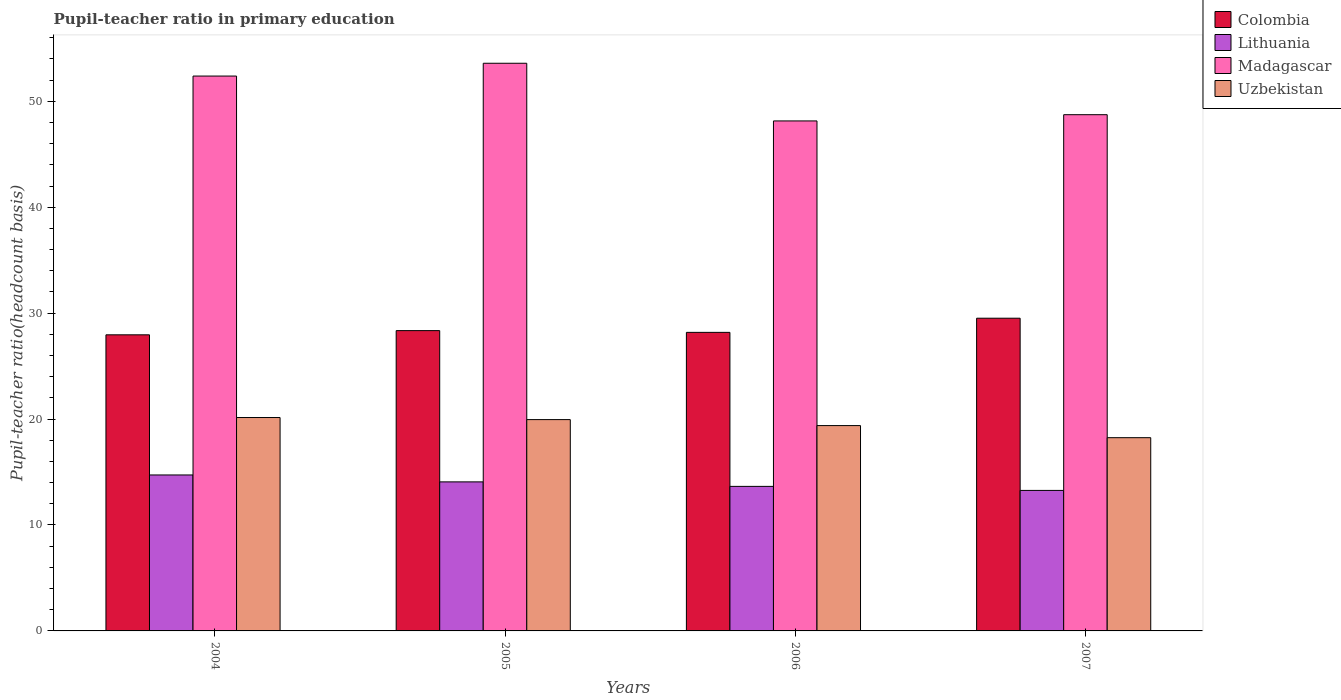Are the number of bars on each tick of the X-axis equal?
Your answer should be very brief. Yes. How many bars are there on the 3rd tick from the right?
Provide a short and direct response. 4. In how many cases, is the number of bars for a given year not equal to the number of legend labels?
Make the answer very short. 0. What is the pupil-teacher ratio in primary education in Lithuania in 2004?
Give a very brief answer. 14.72. Across all years, what is the maximum pupil-teacher ratio in primary education in Lithuania?
Offer a terse response. 14.72. Across all years, what is the minimum pupil-teacher ratio in primary education in Uzbekistan?
Offer a very short reply. 18.24. What is the total pupil-teacher ratio in primary education in Madagascar in the graph?
Offer a very short reply. 202.84. What is the difference between the pupil-teacher ratio in primary education in Madagascar in 2005 and that in 2007?
Your response must be concise. 4.86. What is the difference between the pupil-teacher ratio in primary education in Uzbekistan in 2005 and the pupil-teacher ratio in primary education in Colombia in 2004?
Keep it short and to the point. -8. What is the average pupil-teacher ratio in primary education in Colombia per year?
Your answer should be compact. 28.5. In the year 2007, what is the difference between the pupil-teacher ratio in primary education in Madagascar and pupil-teacher ratio in primary education in Uzbekistan?
Keep it short and to the point. 30.49. What is the ratio of the pupil-teacher ratio in primary education in Lithuania in 2004 to that in 2005?
Make the answer very short. 1.05. What is the difference between the highest and the second highest pupil-teacher ratio in primary education in Lithuania?
Ensure brevity in your answer.  0.65. What is the difference between the highest and the lowest pupil-teacher ratio in primary education in Uzbekistan?
Make the answer very short. 1.9. Is the sum of the pupil-teacher ratio in primary education in Madagascar in 2004 and 2006 greater than the maximum pupil-teacher ratio in primary education in Uzbekistan across all years?
Provide a succinct answer. Yes. Is it the case that in every year, the sum of the pupil-teacher ratio in primary education in Uzbekistan and pupil-teacher ratio in primary education in Lithuania is greater than the sum of pupil-teacher ratio in primary education in Madagascar and pupil-teacher ratio in primary education in Colombia?
Give a very brief answer. No. What does the 2nd bar from the left in 2006 represents?
Your response must be concise. Lithuania. What does the 2nd bar from the right in 2004 represents?
Offer a very short reply. Madagascar. Is it the case that in every year, the sum of the pupil-teacher ratio in primary education in Madagascar and pupil-teacher ratio in primary education in Colombia is greater than the pupil-teacher ratio in primary education in Uzbekistan?
Give a very brief answer. Yes. How many bars are there?
Your answer should be compact. 16. Are all the bars in the graph horizontal?
Your response must be concise. No. How many years are there in the graph?
Your answer should be very brief. 4. What is the difference between two consecutive major ticks on the Y-axis?
Give a very brief answer. 10. Are the values on the major ticks of Y-axis written in scientific E-notation?
Provide a short and direct response. No. Does the graph contain any zero values?
Offer a very short reply. No. Does the graph contain grids?
Your answer should be compact. No. Where does the legend appear in the graph?
Ensure brevity in your answer.  Top right. What is the title of the graph?
Keep it short and to the point. Pupil-teacher ratio in primary education. Does "Cyprus" appear as one of the legend labels in the graph?
Offer a very short reply. No. What is the label or title of the Y-axis?
Keep it short and to the point. Pupil-teacher ratio(headcount basis). What is the Pupil-teacher ratio(headcount basis) in Colombia in 2004?
Give a very brief answer. 27.95. What is the Pupil-teacher ratio(headcount basis) of Lithuania in 2004?
Keep it short and to the point. 14.72. What is the Pupil-teacher ratio(headcount basis) in Madagascar in 2004?
Make the answer very short. 52.38. What is the Pupil-teacher ratio(headcount basis) in Uzbekistan in 2004?
Keep it short and to the point. 20.15. What is the Pupil-teacher ratio(headcount basis) of Colombia in 2005?
Make the answer very short. 28.35. What is the Pupil-teacher ratio(headcount basis) in Lithuania in 2005?
Your response must be concise. 14.07. What is the Pupil-teacher ratio(headcount basis) of Madagascar in 2005?
Make the answer very short. 53.59. What is the Pupil-teacher ratio(headcount basis) in Uzbekistan in 2005?
Offer a terse response. 19.95. What is the Pupil-teacher ratio(headcount basis) of Colombia in 2006?
Your answer should be very brief. 28.18. What is the Pupil-teacher ratio(headcount basis) in Lithuania in 2006?
Provide a succinct answer. 13.64. What is the Pupil-teacher ratio(headcount basis) in Madagascar in 2006?
Keep it short and to the point. 48.14. What is the Pupil-teacher ratio(headcount basis) in Uzbekistan in 2006?
Make the answer very short. 19.38. What is the Pupil-teacher ratio(headcount basis) in Colombia in 2007?
Offer a terse response. 29.52. What is the Pupil-teacher ratio(headcount basis) of Lithuania in 2007?
Make the answer very short. 13.26. What is the Pupil-teacher ratio(headcount basis) of Madagascar in 2007?
Provide a succinct answer. 48.73. What is the Pupil-teacher ratio(headcount basis) of Uzbekistan in 2007?
Provide a short and direct response. 18.24. Across all years, what is the maximum Pupil-teacher ratio(headcount basis) in Colombia?
Your answer should be compact. 29.52. Across all years, what is the maximum Pupil-teacher ratio(headcount basis) of Lithuania?
Provide a succinct answer. 14.72. Across all years, what is the maximum Pupil-teacher ratio(headcount basis) in Madagascar?
Your response must be concise. 53.59. Across all years, what is the maximum Pupil-teacher ratio(headcount basis) of Uzbekistan?
Make the answer very short. 20.15. Across all years, what is the minimum Pupil-teacher ratio(headcount basis) of Colombia?
Offer a very short reply. 27.95. Across all years, what is the minimum Pupil-teacher ratio(headcount basis) in Lithuania?
Your answer should be very brief. 13.26. Across all years, what is the minimum Pupil-teacher ratio(headcount basis) in Madagascar?
Your response must be concise. 48.14. Across all years, what is the minimum Pupil-teacher ratio(headcount basis) of Uzbekistan?
Give a very brief answer. 18.24. What is the total Pupil-teacher ratio(headcount basis) in Colombia in the graph?
Provide a short and direct response. 114. What is the total Pupil-teacher ratio(headcount basis) in Lithuania in the graph?
Your response must be concise. 55.7. What is the total Pupil-teacher ratio(headcount basis) in Madagascar in the graph?
Ensure brevity in your answer.  202.84. What is the total Pupil-teacher ratio(headcount basis) of Uzbekistan in the graph?
Offer a very short reply. 77.72. What is the difference between the Pupil-teacher ratio(headcount basis) in Colombia in 2004 and that in 2005?
Provide a short and direct response. -0.4. What is the difference between the Pupil-teacher ratio(headcount basis) in Lithuania in 2004 and that in 2005?
Ensure brevity in your answer.  0.65. What is the difference between the Pupil-teacher ratio(headcount basis) in Madagascar in 2004 and that in 2005?
Your response must be concise. -1.21. What is the difference between the Pupil-teacher ratio(headcount basis) in Uzbekistan in 2004 and that in 2005?
Give a very brief answer. 0.2. What is the difference between the Pupil-teacher ratio(headcount basis) of Colombia in 2004 and that in 2006?
Provide a short and direct response. -0.23. What is the difference between the Pupil-teacher ratio(headcount basis) of Lithuania in 2004 and that in 2006?
Keep it short and to the point. 1.08. What is the difference between the Pupil-teacher ratio(headcount basis) of Madagascar in 2004 and that in 2006?
Your response must be concise. 4.24. What is the difference between the Pupil-teacher ratio(headcount basis) in Uzbekistan in 2004 and that in 2006?
Offer a terse response. 0.76. What is the difference between the Pupil-teacher ratio(headcount basis) in Colombia in 2004 and that in 2007?
Your answer should be compact. -1.57. What is the difference between the Pupil-teacher ratio(headcount basis) of Lithuania in 2004 and that in 2007?
Offer a terse response. 1.46. What is the difference between the Pupil-teacher ratio(headcount basis) in Madagascar in 2004 and that in 2007?
Offer a very short reply. 3.65. What is the difference between the Pupil-teacher ratio(headcount basis) of Uzbekistan in 2004 and that in 2007?
Make the answer very short. 1.9. What is the difference between the Pupil-teacher ratio(headcount basis) in Colombia in 2005 and that in 2006?
Give a very brief answer. 0.17. What is the difference between the Pupil-teacher ratio(headcount basis) in Lithuania in 2005 and that in 2006?
Provide a short and direct response. 0.43. What is the difference between the Pupil-teacher ratio(headcount basis) in Madagascar in 2005 and that in 2006?
Give a very brief answer. 5.44. What is the difference between the Pupil-teacher ratio(headcount basis) in Uzbekistan in 2005 and that in 2006?
Offer a very short reply. 0.57. What is the difference between the Pupil-teacher ratio(headcount basis) in Colombia in 2005 and that in 2007?
Your answer should be very brief. -1.17. What is the difference between the Pupil-teacher ratio(headcount basis) in Lithuania in 2005 and that in 2007?
Ensure brevity in your answer.  0.81. What is the difference between the Pupil-teacher ratio(headcount basis) of Madagascar in 2005 and that in 2007?
Give a very brief answer. 4.86. What is the difference between the Pupil-teacher ratio(headcount basis) in Uzbekistan in 2005 and that in 2007?
Provide a succinct answer. 1.71. What is the difference between the Pupil-teacher ratio(headcount basis) of Colombia in 2006 and that in 2007?
Make the answer very short. -1.34. What is the difference between the Pupil-teacher ratio(headcount basis) of Lithuania in 2006 and that in 2007?
Provide a succinct answer. 0.38. What is the difference between the Pupil-teacher ratio(headcount basis) of Madagascar in 2006 and that in 2007?
Make the answer very short. -0.59. What is the difference between the Pupil-teacher ratio(headcount basis) of Uzbekistan in 2006 and that in 2007?
Give a very brief answer. 1.14. What is the difference between the Pupil-teacher ratio(headcount basis) in Colombia in 2004 and the Pupil-teacher ratio(headcount basis) in Lithuania in 2005?
Your answer should be compact. 13.88. What is the difference between the Pupil-teacher ratio(headcount basis) in Colombia in 2004 and the Pupil-teacher ratio(headcount basis) in Madagascar in 2005?
Give a very brief answer. -25.64. What is the difference between the Pupil-teacher ratio(headcount basis) of Colombia in 2004 and the Pupil-teacher ratio(headcount basis) of Uzbekistan in 2005?
Provide a succinct answer. 8. What is the difference between the Pupil-teacher ratio(headcount basis) of Lithuania in 2004 and the Pupil-teacher ratio(headcount basis) of Madagascar in 2005?
Provide a succinct answer. -38.86. What is the difference between the Pupil-teacher ratio(headcount basis) of Lithuania in 2004 and the Pupil-teacher ratio(headcount basis) of Uzbekistan in 2005?
Give a very brief answer. -5.23. What is the difference between the Pupil-teacher ratio(headcount basis) of Madagascar in 2004 and the Pupil-teacher ratio(headcount basis) of Uzbekistan in 2005?
Offer a very short reply. 32.43. What is the difference between the Pupil-teacher ratio(headcount basis) in Colombia in 2004 and the Pupil-teacher ratio(headcount basis) in Lithuania in 2006?
Provide a succinct answer. 14.31. What is the difference between the Pupil-teacher ratio(headcount basis) in Colombia in 2004 and the Pupil-teacher ratio(headcount basis) in Madagascar in 2006?
Your response must be concise. -20.19. What is the difference between the Pupil-teacher ratio(headcount basis) in Colombia in 2004 and the Pupil-teacher ratio(headcount basis) in Uzbekistan in 2006?
Give a very brief answer. 8.57. What is the difference between the Pupil-teacher ratio(headcount basis) in Lithuania in 2004 and the Pupil-teacher ratio(headcount basis) in Madagascar in 2006?
Offer a very short reply. -33.42. What is the difference between the Pupil-teacher ratio(headcount basis) in Lithuania in 2004 and the Pupil-teacher ratio(headcount basis) in Uzbekistan in 2006?
Offer a very short reply. -4.66. What is the difference between the Pupil-teacher ratio(headcount basis) of Madagascar in 2004 and the Pupil-teacher ratio(headcount basis) of Uzbekistan in 2006?
Make the answer very short. 33. What is the difference between the Pupil-teacher ratio(headcount basis) in Colombia in 2004 and the Pupil-teacher ratio(headcount basis) in Lithuania in 2007?
Offer a very short reply. 14.69. What is the difference between the Pupil-teacher ratio(headcount basis) in Colombia in 2004 and the Pupil-teacher ratio(headcount basis) in Madagascar in 2007?
Ensure brevity in your answer.  -20.78. What is the difference between the Pupil-teacher ratio(headcount basis) in Colombia in 2004 and the Pupil-teacher ratio(headcount basis) in Uzbekistan in 2007?
Give a very brief answer. 9.71. What is the difference between the Pupil-teacher ratio(headcount basis) in Lithuania in 2004 and the Pupil-teacher ratio(headcount basis) in Madagascar in 2007?
Your response must be concise. -34.01. What is the difference between the Pupil-teacher ratio(headcount basis) of Lithuania in 2004 and the Pupil-teacher ratio(headcount basis) of Uzbekistan in 2007?
Make the answer very short. -3.52. What is the difference between the Pupil-teacher ratio(headcount basis) of Madagascar in 2004 and the Pupil-teacher ratio(headcount basis) of Uzbekistan in 2007?
Give a very brief answer. 34.14. What is the difference between the Pupil-teacher ratio(headcount basis) of Colombia in 2005 and the Pupil-teacher ratio(headcount basis) of Lithuania in 2006?
Offer a very short reply. 14.7. What is the difference between the Pupil-teacher ratio(headcount basis) of Colombia in 2005 and the Pupil-teacher ratio(headcount basis) of Madagascar in 2006?
Your answer should be compact. -19.8. What is the difference between the Pupil-teacher ratio(headcount basis) in Colombia in 2005 and the Pupil-teacher ratio(headcount basis) in Uzbekistan in 2006?
Offer a terse response. 8.97. What is the difference between the Pupil-teacher ratio(headcount basis) of Lithuania in 2005 and the Pupil-teacher ratio(headcount basis) of Madagascar in 2006?
Offer a terse response. -34.07. What is the difference between the Pupil-teacher ratio(headcount basis) in Lithuania in 2005 and the Pupil-teacher ratio(headcount basis) in Uzbekistan in 2006?
Give a very brief answer. -5.31. What is the difference between the Pupil-teacher ratio(headcount basis) of Madagascar in 2005 and the Pupil-teacher ratio(headcount basis) of Uzbekistan in 2006?
Provide a short and direct response. 34.2. What is the difference between the Pupil-teacher ratio(headcount basis) in Colombia in 2005 and the Pupil-teacher ratio(headcount basis) in Lithuania in 2007?
Provide a short and direct response. 15.09. What is the difference between the Pupil-teacher ratio(headcount basis) in Colombia in 2005 and the Pupil-teacher ratio(headcount basis) in Madagascar in 2007?
Offer a terse response. -20.38. What is the difference between the Pupil-teacher ratio(headcount basis) in Colombia in 2005 and the Pupil-teacher ratio(headcount basis) in Uzbekistan in 2007?
Ensure brevity in your answer.  10.11. What is the difference between the Pupil-teacher ratio(headcount basis) of Lithuania in 2005 and the Pupil-teacher ratio(headcount basis) of Madagascar in 2007?
Your answer should be compact. -34.66. What is the difference between the Pupil-teacher ratio(headcount basis) of Lithuania in 2005 and the Pupil-teacher ratio(headcount basis) of Uzbekistan in 2007?
Ensure brevity in your answer.  -4.17. What is the difference between the Pupil-teacher ratio(headcount basis) in Madagascar in 2005 and the Pupil-teacher ratio(headcount basis) in Uzbekistan in 2007?
Make the answer very short. 35.35. What is the difference between the Pupil-teacher ratio(headcount basis) in Colombia in 2006 and the Pupil-teacher ratio(headcount basis) in Lithuania in 2007?
Ensure brevity in your answer.  14.92. What is the difference between the Pupil-teacher ratio(headcount basis) of Colombia in 2006 and the Pupil-teacher ratio(headcount basis) of Madagascar in 2007?
Keep it short and to the point. -20.55. What is the difference between the Pupil-teacher ratio(headcount basis) of Colombia in 2006 and the Pupil-teacher ratio(headcount basis) of Uzbekistan in 2007?
Provide a succinct answer. 9.94. What is the difference between the Pupil-teacher ratio(headcount basis) of Lithuania in 2006 and the Pupil-teacher ratio(headcount basis) of Madagascar in 2007?
Make the answer very short. -35.09. What is the difference between the Pupil-teacher ratio(headcount basis) in Lithuania in 2006 and the Pupil-teacher ratio(headcount basis) in Uzbekistan in 2007?
Make the answer very short. -4.6. What is the difference between the Pupil-teacher ratio(headcount basis) of Madagascar in 2006 and the Pupil-teacher ratio(headcount basis) of Uzbekistan in 2007?
Keep it short and to the point. 29.9. What is the average Pupil-teacher ratio(headcount basis) in Colombia per year?
Offer a very short reply. 28.5. What is the average Pupil-teacher ratio(headcount basis) in Lithuania per year?
Provide a succinct answer. 13.93. What is the average Pupil-teacher ratio(headcount basis) of Madagascar per year?
Your answer should be compact. 50.71. What is the average Pupil-teacher ratio(headcount basis) of Uzbekistan per year?
Provide a short and direct response. 19.43. In the year 2004, what is the difference between the Pupil-teacher ratio(headcount basis) in Colombia and Pupil-teacher ratio(headcount basis) in Lithuania?
Offer a very short reply. 13.23. In the year 2004, what is the difference between the Pupil-teacher ratio(headcount basis) of Colombia and Pupil-teacher ratio(headcount basis) of Madagascar?
Offer a very short reply. -24.43. In the year 2004, what is the difference between the Pupil-teacher ratio(headcount basis) in Colombia and Pupil-teacher ratio(headcount basis) in Uzbekistan?
Your answer should be compact. 7.81. In the year 2004, what is the difference between the Pupil-teacher ratio(headcount basis) in Lithuania and Pupil-teacher ratio(headcount basis) in Madagascar?
Provide a short and direct response. -37.66. In the year 2004, what is the difference between the Pupil-teacher ratio(headcount basis) in Lithuania and Pupil-teacher ratio(headcount basis) in Uzbekistan?
Provide a succinct answer. -5.42. In the year 2004, what is the difference between the Pupil-teacher ratio(headcount basis) of Madagascar and Pupil-teacher ratio(headcount basis) of Uzbekistan?
Your response must be concise. 32.23. In the year 2005, what is the difference between the Pupil-teacher ratio(headcount basis) in Colombia and Pupil-teacher ratio(headcount basis) in Lithuania?
Your answer should be compact. 14.28. In the year 2005, what is the difference between the Pupil-teacher ratio(headcount basis) in Colombia and Pupil-teacher ratio(headcount basis) in Madagascar?
Your response must be concise. -25.24. In the year 2005, what is the difference between the Pupil-teacher ratio(headcount basis) in Colombia and Pupil-teacher ratio(headcount basis) in Uzbekistan?
Offer a very short reply. 8.4. In the year 2005, what is the difference between the Pupil-teacher ratio(headcount basis) of Lithuania and Pupil-teacher ratio(headcount basis) of Madagascar?
Offer a very short reply. -39.52. In the year 2005, what is the difference between the Pupil-teacher ratio(headcount basis) in Lithuania and Pupil-teacher ratio(headcount basis) in Uzbekistan?
Make the answer very short. -5.88. In the year 2005, what is the difference between the Pupil-teacher ratio(headcount basis) of Madagascar and Pupil-teacher ratio(headcount basis) of Uzbekistan?
Keep it short and to the point. 33.64. In the year 2006, what is the difference between the Pupil-teacher ratio(headcount basis) of Colombia and Pupil-teacher ratio(headcount basis) of Lithuania?
Keep it short and to the point. 14.54. In the year 2006, what is the difference between the Pupil-teacher ratio(headcount basis) of Colombia and Pupil-teacher ratio(headcount basis) of Madagascar?
Make the answer very short. -19.96. In the year 2006, what is the difference between the Pupil-teacher ratio(headcount basis) of Colombia and Pupil-teacher ratio(headcount basis) of Uzbekistan?
Ensure brevity in your answer.  8.8. In the year 2006, what is the difference between the Pupil-teacher ratio(headcount basis) of Lithuania and Pupil-teacher ratio(headcount basis) of Madagascar?
Keep it short and to the point. -34.5. In the year 2006, what is the difference between the Pupil-teacher ratio(headcount basis) in Lithuania and Pupil-teacher ratio(headcount basis) in Uzbekistan?
Make the answer very short. -5.74. In the year 2006, what is the difference between the Pupil-teacher ratio(headcount basis) in Madagascar and Pupil-teacher ratio(headcount basis) in Uzbekistan?
Provide a succinct answer. 28.76. In the year 2007, what is the difference between the Pupil-teacher ratio(headcount basis) of Colombia and Pupil-teacher ratio(headcount basis) of Lithuania?
Offer a very short reply. 16.26. In the year 2007, what is the difference between the Pupil-teacher ratio(headcount basis) in Colombia and Pupil-teacher ratio(headcount basis) in Madagascar?
Offer a terse response. -19.21. In the year 2007, what is the difference between the Pupil-teacher ratio(headcount basis) of Colombia and Pupil-teacher ratio(headcount basis) of Uzbekistan?
Give a very brief answer. 11.28. In the year 2007, what is the difference between the Pupil-teacher ratio(headcount basis) in Lithuania and Pupil-teacher ratio(headcount basis) in Madagascar?
Offer a very short reply. -35.47. In the year 2007, what is the difference between the Pupil-teacher ratio(headcount basis) in Lithuania and Pupil-teacher ratio(headcount basis) in Uzbekistan?
Provide a succinct answer. -4.98. In the year 2007, what is the difference between the Pupil-teacher ratio(headcount basis) of Madagascar and Pupil-teacher ratio(headcount basis) of Uzbekistan?
Provide a succinct answer. 30.49. What is the ratio of the Pupil-teacher ratio(headcount basis) of Colombia in 2004 to that in 2005?
Your response must be concise. 0.99. What is the ratio of the Pupil-teacher ratio(headcount basis) in Lithuania in 2004 to that in 2005?
Give a very brief answer. 1.05. What is the ratio of the Pupil-teacher ratio(headcount basis) of Madagascar in 2004 to that in 2005?
Provide a short and direct response. 0.98. What is the ratio of the Pupil-teacher ratio(headcount basis) in Uzbekistan in 2004 to that in 2005?
Ensure brevity in your answer.  1.01. What is the ratio of the Pupil-teacher ratio(headcount basis) in Lithuania in 2004 to that in 2006?
Make the answer very short. 1.08. What is the ratio of the Pupil-teacher ratio(headcount basis) in Madagascar in 2004 to that in 2006?
Your answer should be compact. 1.09. What is the ratio of the Pupil-teacher ratio(headcount basis) in Uzbekistan in 2004 to that in 2006?
Offer a terse response. 1.04. What is the ratio of the Pupil-teacher ratio(headcount basis) of Colombia in 2004 to that in 2007?
Your answer should be very brief. 0.95. What is the ratio of the Pupil-teacher ratio(headcount basis) in Lithuania in 2004 to that in 2007?
Offer a very short reply. 1.11. What is the ratio of the Pupil-teacher ratio(headcount basis) in Madagascar in 2004 to that in 2007?
Ensure brevity in your answer.  1.07. What is the ratio of the Pupil-teacher ratio(headcount basis) of Uzbekistan in 2004 to that in 2007?
Keep it short and to the point. 1.1. What is the ratio of the Pupil-teacher ratio(headcount basis) of Colombia in 2005 to that in 2006?
Your response must be concise. 1.01. What is the ratio of the Pupil-teacher ratio(headcount basis) in Lithuania in 2005 to that in 2006?
Provide a succinct answer. 1.03. What is the ratio of the Pupil-teacher ratio(headcount basis) of Madagascar in 2005 to that in 2006?
Ensure brevity in your answer.  1.11. What is the ratio of the Pupil-teacher ratio(headcount basis) in Uzbekistan in 2005 to that in 2006?
Provide a succinct answer. 1.03. What is the ratio of the Pupil-teacher ratio(headcount basis) in Colombia in 2005 to that in 2007?
Offer a very short reply. 0.96. What is the ratio of the Pupil-teacher ratio(headcount basis) of Lithuania in 2005 to that in 2007?
Your answer should be compact. 1.06. What is the ratio of the Pupil-teacher ratio(headcount basis) of Madagascar in 2005 to that in 2007?
Provide a short and direct response. 1.1. What is the ratio of the Pupil-teacher ratio(headcount basis) of Uzbekistan in 2005 to that in 2007?
Your answer should be very brief. 1.09. What is the ratio of the Pupil-teacher ratio(headcount basis) of Colombia in 2006 to that in 2007?
Provide a short and direct response. 0.95. What is the ratio of the Pupil-teacher ratio(headcount basis) of Lithuania in 2006 to that in 2007?
Your response must be concise. 1.03. What is the ratio of the Pupil-teacher ratio(headcount basis) of Madagascar in 2006 to that in 2007?
Make the answer very short. 0.99. What is the ratio of the Pupil-teacher ratio(headcount basis) in Uzbekistan in 2006 to that in 2007?
Offer a very short reply. 1.06. What is the difference between the highest and the second highest Pupil-teacher ratio(headcount basis) of Colombia?
Your response must be concise. 1.17. What is the difference between the highest and the second highest Pupil-teacher ratio(headcount basis) of Lithuania?
Provide a succinct answer. 0.65. What is the difference between the highest and the second highest Pupil-teacher ratio(headcount basis) of Madagascar?
Give a very brief answer. 1.21. What is the difference between the highest and the second highest Pupil-teacher ratio(headcount basis) of Uzbekistan?
Make the answer very short. 0.2. What is the difference between the highest and the lowest Pupil-teacher ratio(headcount basis) in Colombia?
Give a very brief answer. 1.57. What is the difference between the highest and the lowest Pupil-teacher ratio(headcount basis) in Lithuania?
Ensure brevity in your answer.  1.46. What is the difference between the highest and the lowest Pupil-teacher ratio(headcount basis) of Madagascar?
Offer a very short reply. 5.44. What is the difference between the highest and the lowest Pupil-teacher ratio(headcount basis) of Uzbekistan?
Offer a very short reply. 1.9. 